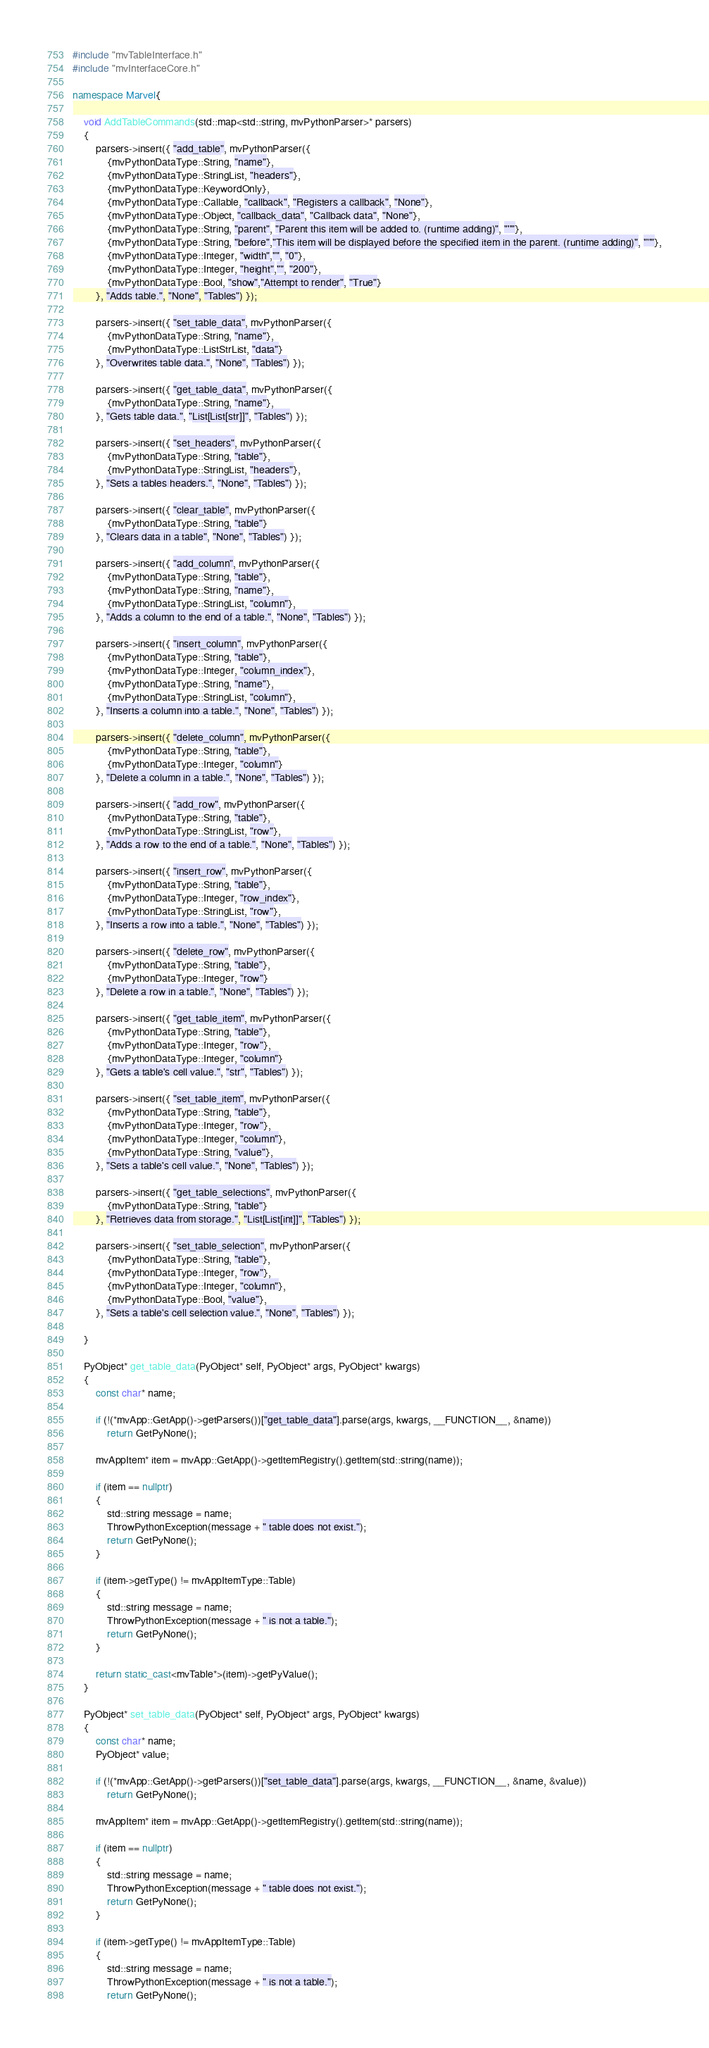Convert code to text. <code><loc_0><loc_0><loc_500><loc_500><_C++_>#include "mvTableInterface.h"
#include "mvInterfaceCore.h"

namespace Marvel{

	void AddTableCommands(std::map<std::string, mvPythonParser>* parsers)
	{
		parsers->insert({ "add_table", mvPythonParser({
			{mvPythonDataType::String, "name"},
			{mvPythonDataType::StringList, "headers"},
			{mvPythonDataType::KeywordOnly},
			{mvPythonDataType::Callable, "callback", "Registers a callback", "None"},
			{mvPythonDataType::Object, "callback_data", "Callback data", "None"},
			{mvPythonDataType::String, "parent", "Parent this item will be added to. (runtime adding)", "''"},
			{mvPythonDataType::String, "before","This item will be displayed before the specified item in the parent. (runtime adding)", "''"},
			{mvPythonDataType::Integer, "width","", "0"},
			{mvPythonDataType::Integer, "height","", "200"},
			{mvPythonDataType::Bool, "show","Attempt to render", "True"}
		}, "Adds table.", "None", "Tables") });

		parsers->insert({ "set_table_data", mvPythonParser({
			{mvPythonDataType::String, "name"},
			{mvPythonDataType::ListStrList, "data"}
		}, "Overwrites table data.", "None", "Tables") });

		parsers->insert({ "get_table_data", mvPythonParser({
			{mvPythonDataType::String, "name"},
		}, "Gets table data.", "List[List[str]]", "Tables") });

		parsers->insert({ "set_headers", mvPythonParser({
			{mvPythonDataType::String, "table"},
			{mvPythonDataType::StringList, "headers"},
		}, "Sets a tables headers.", "None", "Tables") });

		parsers->insert({ "clear_table", mvPythonParser({
			{mvPythonDataType::String, "table"}
		}, "Clears data in a table", "None", "Tables") });

		parsers->insert({ "add_column", mvPythonParser({
			{mvPythonDataType::String, "table"},
			{mvPythonDataType::String, "name"},
			{mvPythonDataType::StringList, "column"},
		}, "Adds a column to the end of a table.", "None", "Tables") });

		parsers->insert({ "insert_column", mvPythonParser({
			{mvPythonDataType::String, "table"},
			{mvPythonDataType::Integer, "column_index"},
			{mvPythonDataType::String, "name"},
			{mvPythonDataType::StringList, "column"},
		}, "Inserts a column into a table.", "None", "Tables") });

		parsers->insert({ "delete_column", mvPythonParser({
			{mvPythonDataType::String, "table"},
			{mvPythonDataType::Integer, "column"}
		}, "Delete a column in a table.", "None", "Tables") });

		parsers->insert({ "add_row", mvPythonParser({
			{mvPythonDataType::String, "table"},
			{mvPythonDataType::StringList, "row"},
		}, "Adds a row to the end of a table.", "None", "Tables") });

		parsers->insert({ "insert_row", mvPythonParser({
			{mvPythonDataType::String, "table"},
			{mvPythonDataType::Integer, "row_index"},
			{mvPythonDataType::StringList, "row"},
		}, "Inserts a row into a table.", "None", "Tables") });

		parsers->insert({ "delete_row", mvPythonParser({
			{mvPythonDataType::String, "table"},
			{mvPythonDataType::Integer, "row"}
		}, "Delete a row in a table.", "None", "Tables") });

		parsers->insert({ "get_table_item", mvPythonParser({
			{mvPythonDataType::String, "table"},
			{mvPythonDataType::Integer, "row"},
			{mvPythonDataType::Integer, "column"}
		}, "Gets a table's cell value.", "str", "Tables") });

		parsers->insert({ "set_table_item", mvPythonParser({
			{mvPythonDataType::String, "table"},
			{mvPythonDataType::Integer, "row"},
			{mvPythonDataType::Integer, "column"},
			{mvPythonDataType::String, "value"},
		}, "Sets a table's cell value.", "None", "Tables") });

		parsers->insert({ "get_table_selections", mvPythonParser({
			{mvPythonDataType::String, "table"}
		}, "Retrieves data from storage.", "List[List[int]]", "Tables") });

		parsers->insert({ "set_table_selection", mvPythonParser({
			{mvPythonDataType::String, "table"},
			{mvPythonDataType::Integer, "row"},
			{mvPythonDataType::Integer, "column"},
			{mvPythonDataType::Bool, "value"},
		}, "Sets a table's cell selection value.", "None", "Tables") });

	}

	PyObject* get_table_data(PyObject* self, PyObject* args, PyObject* kwargs)
	{
		const char* name;

		if (!(*mvApp::GetApp()->getParsers())["get_table_data"].parse(args, kwargs, __FUNCTION__, &name))
			return GetPyNone();

		mvAppItem* item = mvApp::GetApp()->getItemRegistry().getItem(std::string(name));

		if (item == nullptr)
		{
			std::string message = name;
			ThrowPythonException(message + " table does not exist.");
			return GetPyNone();
		}

		if (item->getType() != mvAppItemType::Table)
		{
			std::string message = name;
			ThrowPythonException(message + " is not a table.");
			return GetPyNone();
		}

		return static_cast<mvTable*>(item)->getPyValue();
	}

	PyObject* set_table_data(PyObject* self, PyObject* args, PyObject* kwargs)
	{
		const char* name;
		PyObject* value;

		if (!(*mvApp::GetApp()->getParsers())["set_table_data"].parse(args, kwargs, __FUNCTION__, &name, &value))
			return GetPyNone();

		mvAppItem* item = mvApp::GetApp()->getItemRegistry().getItem(std::string(name));

		if (item == nullptr)
		{
			std::string message = name;
			ThrowPythonException(message + " table does not exist.");
			return GetPyNone();
		}

		if (item->getType() != mvAppItemType::Table)
		{
			std::string message = name;
			ThrowPythonException(message + " is not a table.");
			return GetPyNone();</code> 